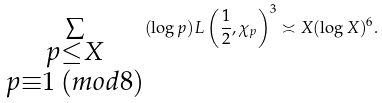Convert formula to latex. <formula><loc_0><loc_0><loc_500><loc_500>\sum _ { \substack { p \leq X \\ p \equiv 1 \, ( m o d 8 ) } } ( \log p ) L \left ( \frac { 1 } { 2 } , \chi _ { p } \right ) ^ { 3 } \asymp X ( \log X ) ^ { 6 } .</formula> 